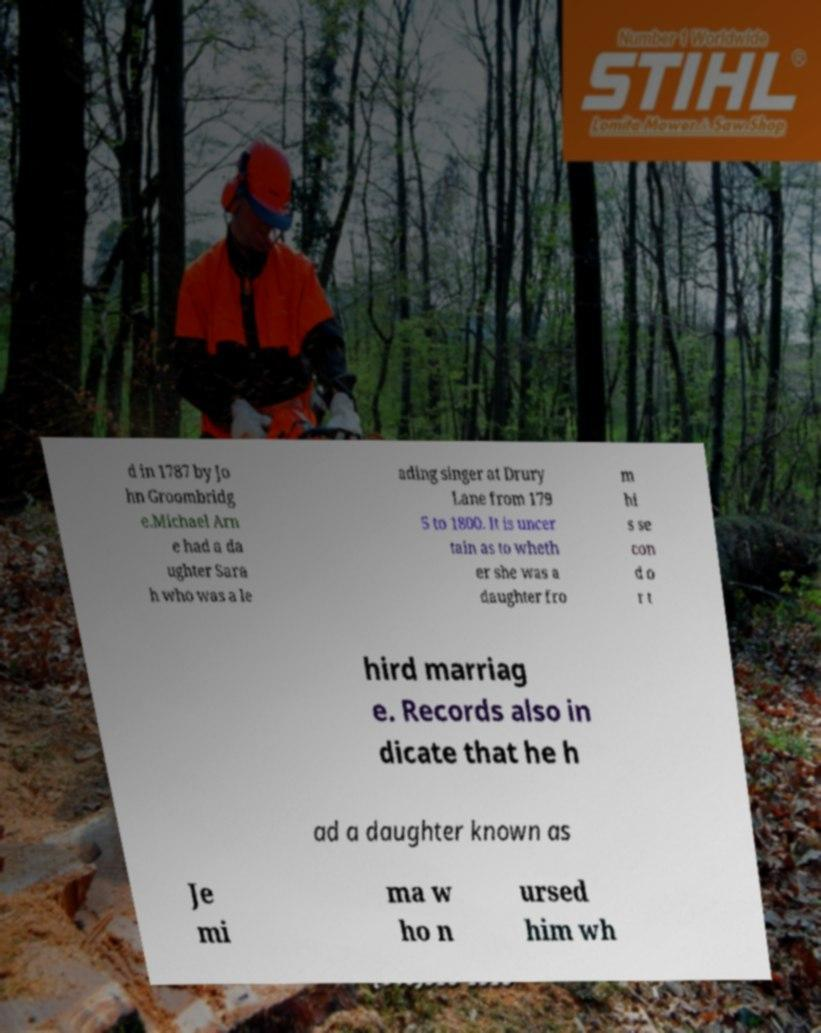I need the written content from this picture converted into text. Can you do that? d in 1787 by Jo hn Groombridg e.Michael Arn e had a da ughter Sara h who was a le ading singer at Drury Lane from 179 5 to 1800. It is uncer tain as to wheth er she was a daughter fro m hi s se con d o r t hird marriag e. Records also in dicate that he h ad a daughter known as Je mi ma w ho n ursed him wh 